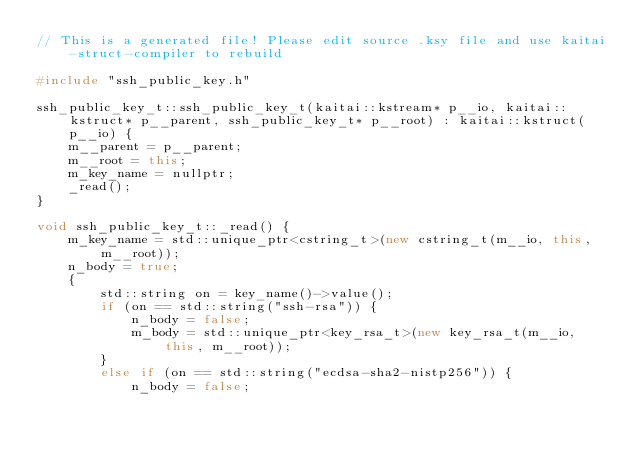Convert code to text. <code><loc_0><loc_0><loc_500><loc_500><_C++_>// This is a generated file! Please edit source .ksy file and use kaitai-struct-compiler to rebuild

#include "ssh_public_key.h"

ssh_public_key_t::ssh_public_key_t(kaitai::kstream* p__io, kaitai::kstruct* p__parent, ssh_public_key_t* p__root) : kaitai::kstruct(p__io) {
    m__parent = p__parent;
    m__root = this;
    m_key_name = nullptr;
    _read();
}

void ssh_public_key_t::_read() {
    m_key_name = std::unique_ptr<cstring_t>(new cstring_t(m__io, this, m__root));
    n_body = true;
    {
        std::string on = key_name()->value();
        if (on == std::string("ssh-rsa")) {
            n_body = false;
            m_body = std::unique_ptr<key_rsa_t>(new key_rsa_t(m__io, this, m__root));
        }
        else if (on == std::string("ecdsa-sha2-nistp256")) {
            n_body = false;</code> 